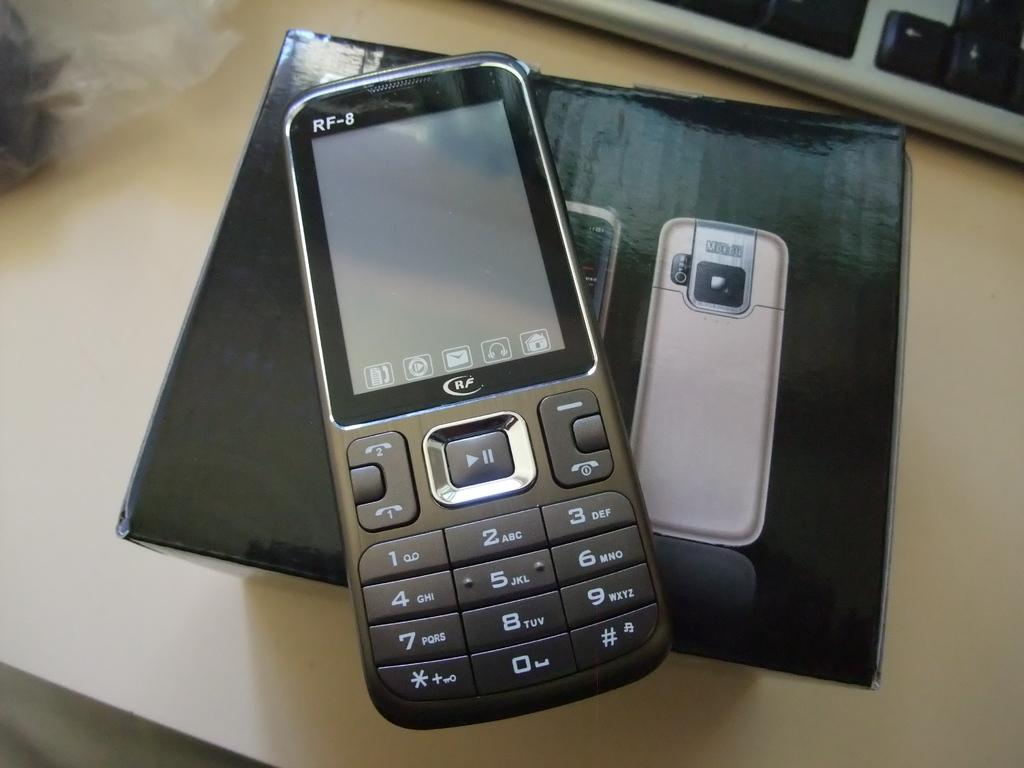<image>
Relay a brief, clear account of the picture shown. RF-8 Smartphone that is laying on top of a black case on a table. 